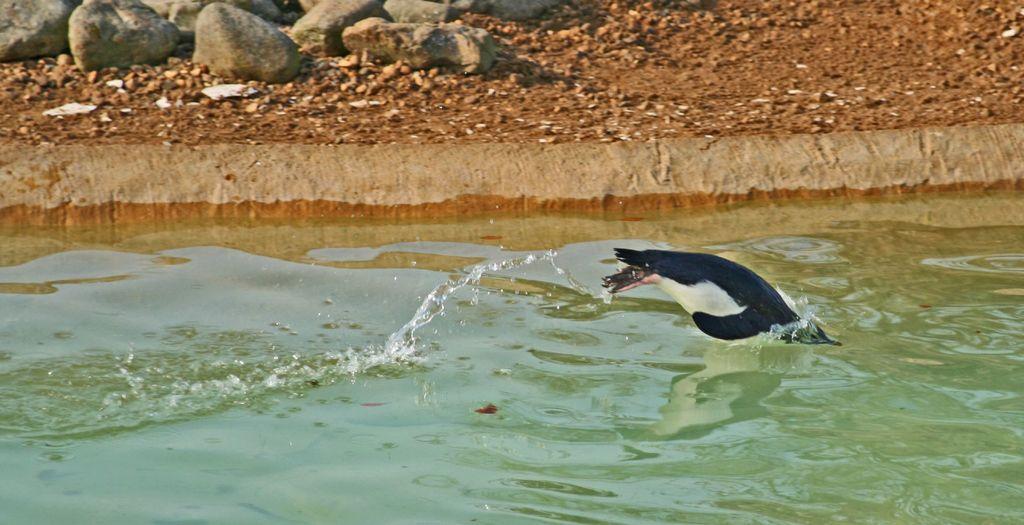Could you give a brief overview of what you see in this image? In this picture we can see an animal, water and in the background we can see stones on the ground. 